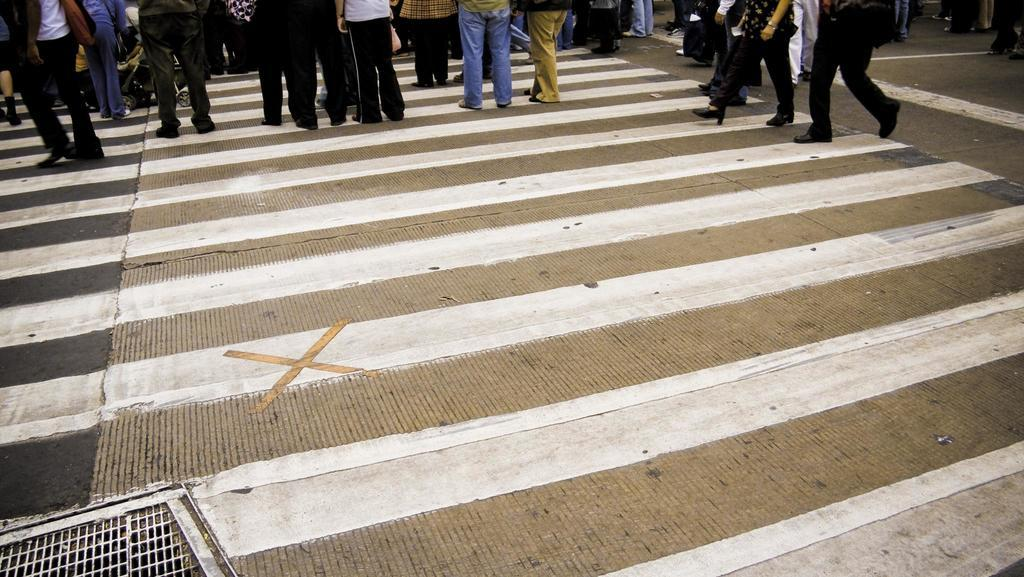What can be seen in the image? There are people standing in the image. Can you describe the clothing of the people? The people are wearing different color dresses. What else is present in the image besides the people? There is a trolley on the road in the image. What type of lettuce can be seen growing on the people's heads in the image? There is no lettuce present in the image, nor is it growing on the people's heads. 